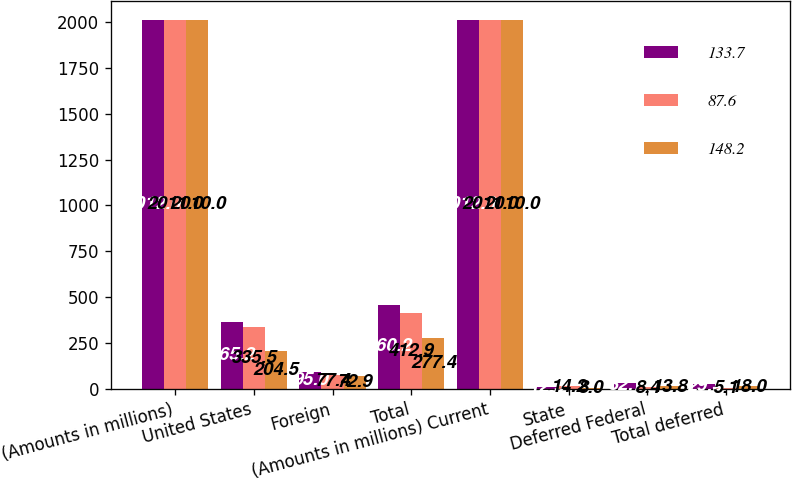Convert chart. <chart><loc_0><loc_0><loc_500><loc_500><stacked_bar_chart><ecel><fcel>(Amounts in millions)<fcel>United States<fcel>Foreign<fcel>Total<fcel>(Amounts in millions) Current<fcel>State<fcel>Deferred Federal<fcel>Total deferred<nl><fcel>133.7<fcel>2012<fcel>365.2<fcel>95<fcel>460.2<fcel>2012<fcel>12.5<fcel>32.7<fcel>29.3<nl><fcel>87.6<fcel>2011<fcel>335.5<fcel>77.4<fcel>412.9<fcel>2011<fcel>14.2<fcel>8.4<fcel>5.1<nl><fcel>148.2<fcel>2010<fcel>204.5<fcel>72.9<fcel>277.4<fcel>2010<fcel>8<fcel>13.8<fcel>18<nl></chart> 